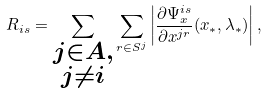Convert formula to latex. <formula><loc_0><loc_0><loc_500><loc_500>R _ { i s } = \sum _ { \substack { j \in A , \\ j \neq i } } \sum _ { r \in S ^ { j } } \left | \frac { \partial \Psi _ { x } ^ { i s } } { \partial x ^ { j r } } ( x _ { * } , \lambda _ { * } ) \right | ,</formula> 